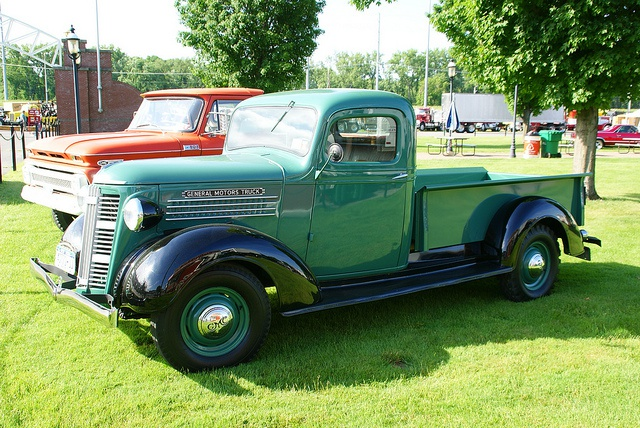Describe the objects in this image and their specific colors. I can see truck in white, black, teal, and darkgreen tones, truck in white, brown, tan, and salmon tones, truck in white, lightgray, black, and darkgray tones, car in white, brown, lightgray, blue, and maroon tones, and car in white, lavender, darkgray, and brown tones in this image. 